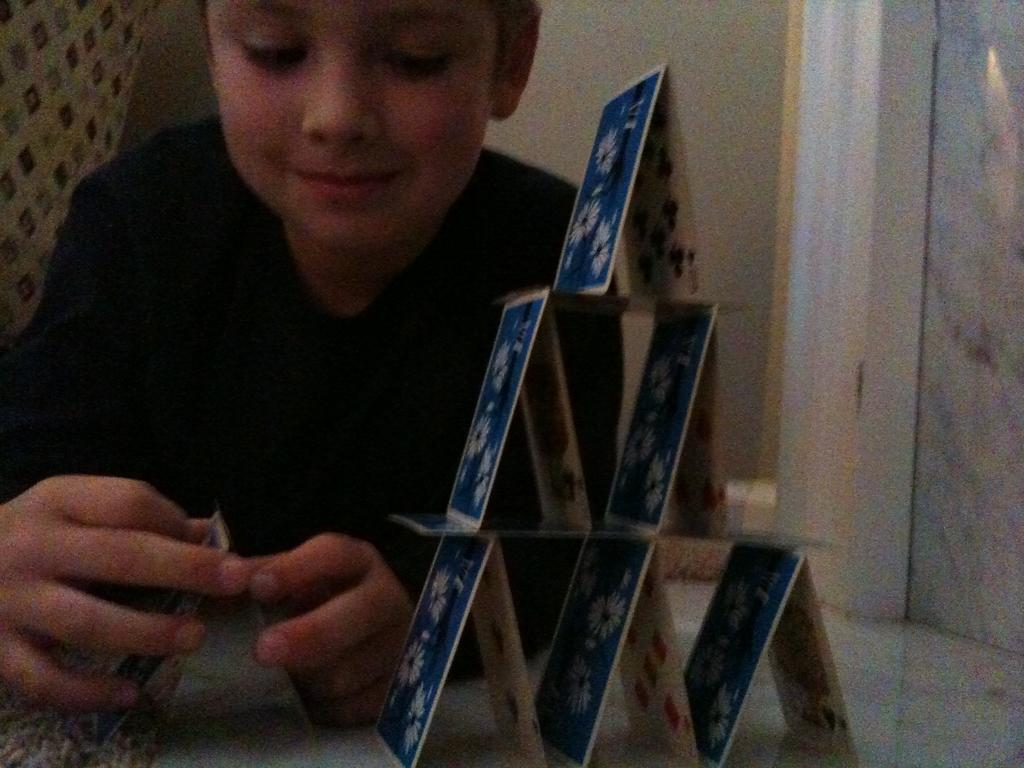What is the main subject of the image? The main subject of the image is a kid. What is the kid wearing in the image? The kid is wearing a black T-shirt. What activity is the kid engaged in? The kid is playing with cards. What color are the cards? The cards are blue in color. What can be seen in the background of the image? There is a wall in the background of the image. What type of food is the kid eating in the image? There is no food present in the image; the kid is playing with blue cards. 